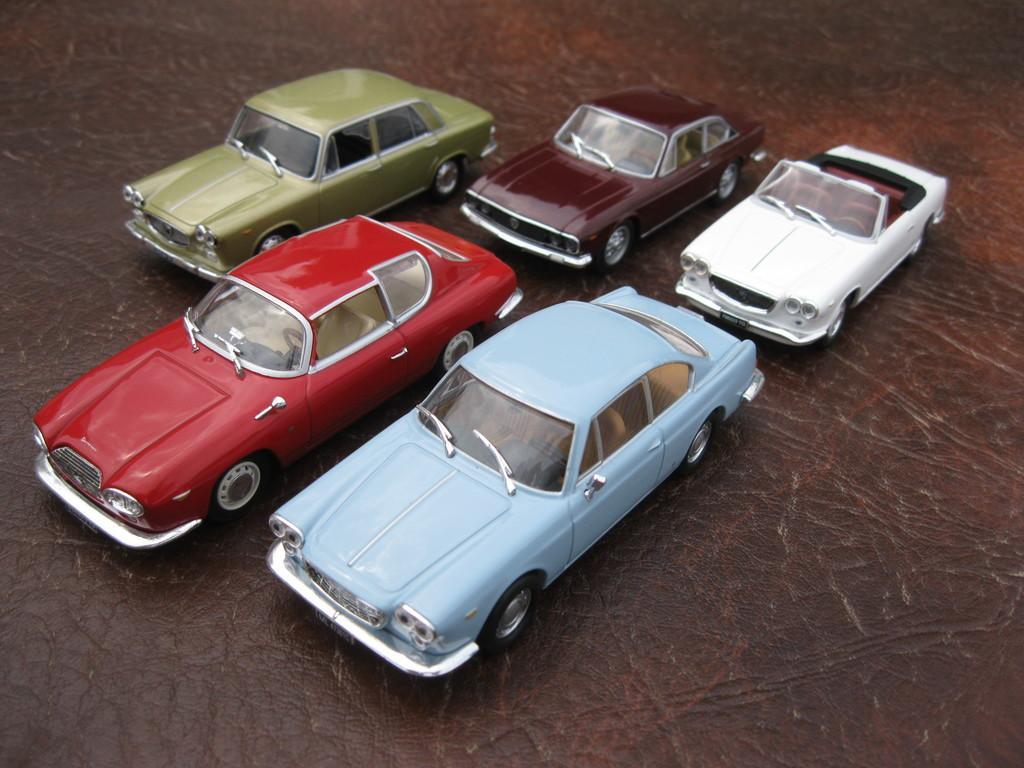Could you give a brief overview of what you see in this image? In this image, we can see five cars on the ground. 